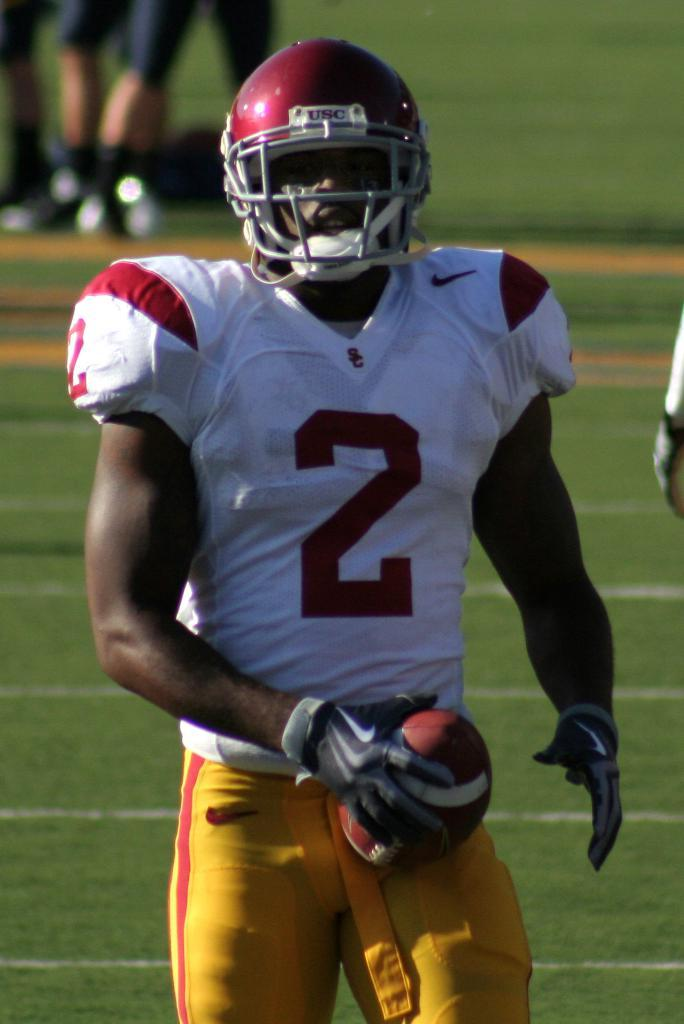Who is present in the image? There is a man in the image. What is the man holding in the image? The man is holding a ball. What type of surface can be seen in the background of the image? There is ground visible in the background of the image. Can you describe any other people in the image? There are legs of people visible in the background of the image. What type of mitten is the man wearing in the image? The man is not wearing a mitten in the image; he is holding a ball. What flavor of jam is being spread on the bread in the image? There is no bread or jam present in the image; it features a man holding a ball. 